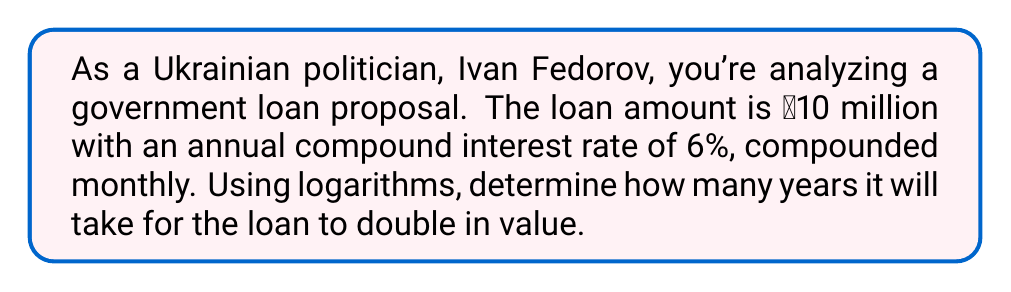Can you solve this math problem? To solve this problem, we'll use the compound interest formula and logarithms:

1) The compound interest formula is:
   $$A = P(1 + \frac{r}{n})^{nt}$$
   where:
   $A$ = final amount
   $P$ = principal (initial investment)
   $r$ = annual interest rate (in decimal form)
   $n$ = number of times interest is compounded per year
   $t$ = number of years

2) We want to find when the amount doubles, so:
   $$2P = P(1 + \frac{r}{n})^{nt}$$

3) Divide both sides by $P$:
   $$2 = (1 + \frac{r}{n})^{nt}$$

4) Take the natural logarithm of both sides:
   $$\ln(2) = nt \ln(1 + \frac{r}{n})$$

5) Solve for $t$:
   $$t = \frac{\ln(2)}{n \ln(1 + \frac{r}{n})}$$

6) Now, let's plug in our values:
   $r = 0.06$ (6% in decimal form)
   $n = 12$ (compounded monthly)

   $$t = \frac{\ln(2)}{12 \ln(1 + \frac{0.06}{12})}$$

7) Calculate:
   $$t = \frac{0.693147}{12 \times 0.004989} \approx 11.57$$
Answer: It will take approximately 11.57 years for the government loan to double in value. 